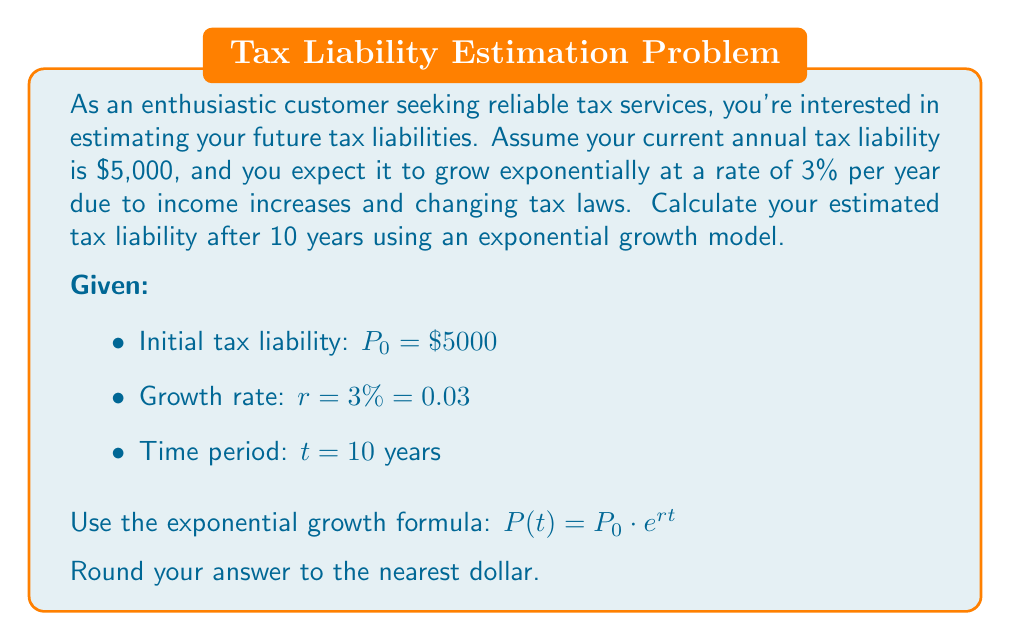Help me with this question. To solve this problem, we'll use the exponential growth formula:

$P(t) = P_0 \cdot e^{rt}$

Where:
$P(t)$ is the final amount after time $t$
$P_0$ is the initial amount
$e$ is Euler's number (approximately 2.71828)
$r$ is the growth rate (as a decimal)
$t$ is the time period

Step 1: Substitute the given values into the formula
$P(10) = 5000 \cdot e^{0.03 \cdot 10}$

Step 2: Simplify the exponent
$P(10) = 5000 \cdot e^{0.3}$

Step 3: Calculate $e^{0.3}$ (using a calculator)
$e^{0.3} \approx 1.34986$

Step 4: Multiply by the initial amount
$P(10) = 5000 \cdot 1.34986 = 6749.30$

Step 5: Round to the nearest dollar
$P(10) \approx 6749$

Therefore, the estimated tax liability after 10 years is $6,749.
Answer: $6,749 